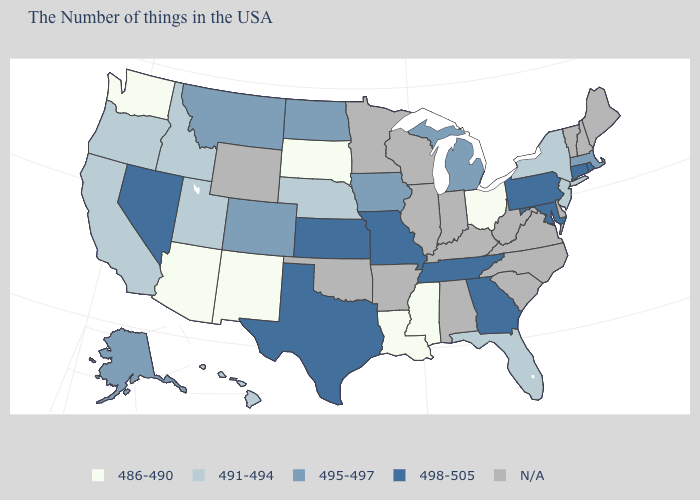Name the states that have a value in the range 491-494?
Quick response, please. New York, New Jersey, Florida, Nebraska, Utah, Idaho, California, Oregon, Hawaii. Name the states that have a value in the range 486-490?
Concise answer only. Ohio, Mississippi, Louisiana, South Dakota, New Mexico, Arizona, Washington. What is the value of North Carolina?
Quick response, please. N/A. Name the states that have a value in the range 486-490?
Short answer required. Ohio, Mississippi, Louisiana, South Dakota, New Mexico, Arizona, Washington. What is the value of Maryland?
Quick response, please. 498-505. Which states have the lowest value in the South?
Answer briefly. Mississippi, Louisiana. Name the states that have a value in the range N/A?
Give a very brief answer. Maine, New Hampshire, Vermont, Delaware, Virginia, North Carolina, South Carolina, West Virginia, Kentucky, Indiana, Alabama, Wisconsin, Illinois, Arkansas, Minnesota, Oklahoma, Wyoming. Among the states that border Colorado , which have the highest value?
Give a very brief answer. Kansas. Does Montana have the highest value in the West?
Be succinct. No. Name the states that have a value in the range 491-494?
Be succinct. New York, New Jersey, Florida, Nebraska, Utah, Idaho, California, Oregon, Hawaii. Name the states that have a value in the range 491-494?
Concise answer only. New York, New Jersey, Florida, Nebraska, Utah, Idaho, California, Oregon, Hawaii. What is the lowest value in the USA?
Quick response, please. 486-490. What is the value of Delaware?
Quick response, please. N/A. 